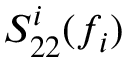<formula> <loc_0><loc_0><loc_500><loc_500>S _ { 2 2 } ^ { i } ( f _ { i } )</formula> 